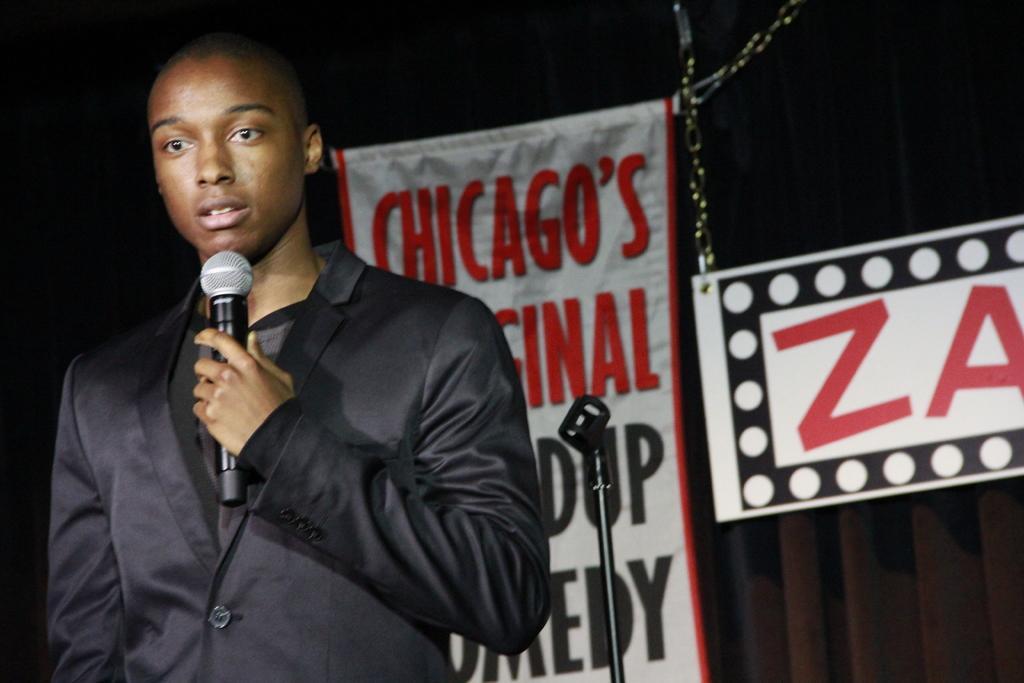Could you give a brief overview of what you see in this image? In this image there is a person wearing a black blazer standing and holding a microphone in his hand, and at the back ground there is name board and banner. 